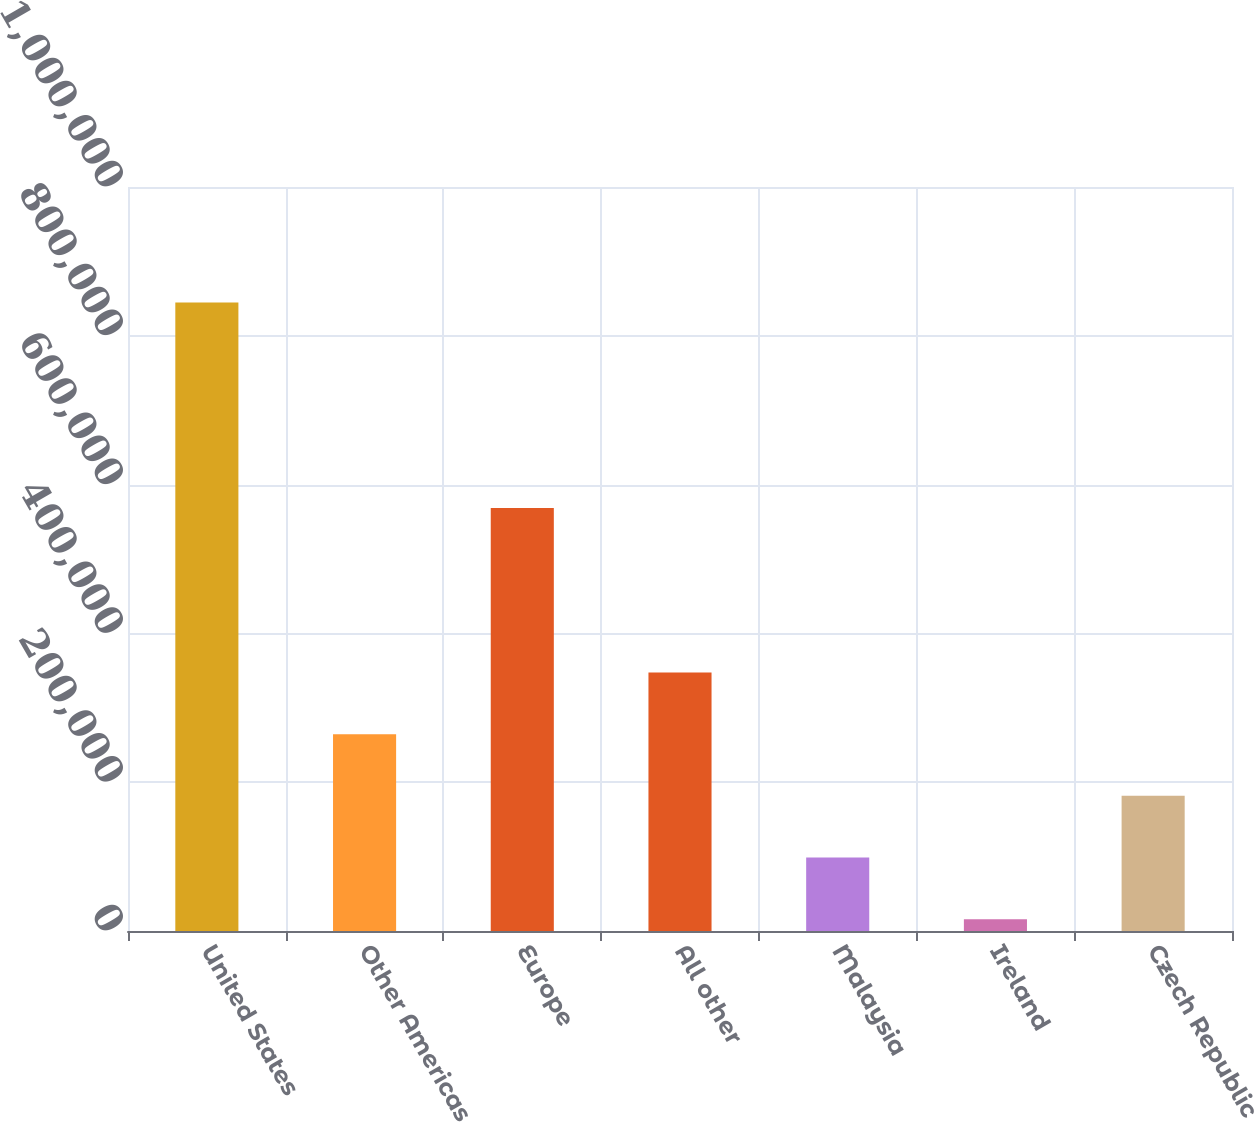Convert chart to OTSL. <chart><loc_0><loc_0><loc_500><loc_500><bar_chart><fcel>United States<fcel>Other Americas<fcel>Europe<fcel>All other<fcel>Malaysia<fcel>Ireland<fcel>Czech Republic<nl><fcel>844884<fcel>264614<fcel>568559<fcel>347510<fcel>98822.7<fcel>15927<fcel>181718<nl></chart> 